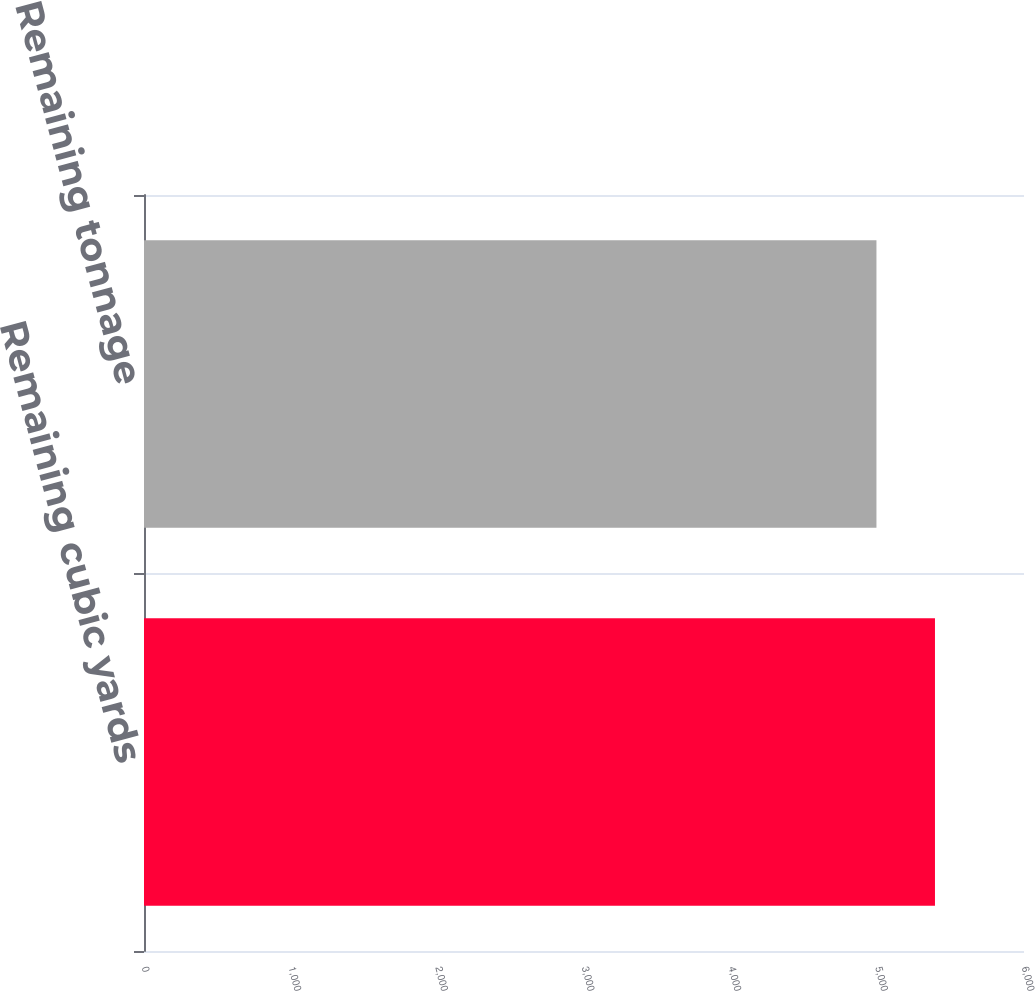Convert chart to OTSL. <chart><loc_0><loc_0><loc_500><loc_500><bar_chart><fcel>Remaining cubic yards<fcel>Remaining tonnage<nl><fcel>5393<fcel>4994<nl></chart> 